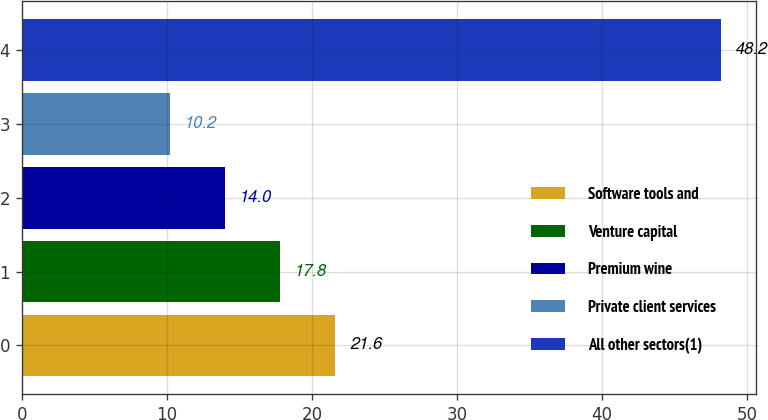Convert chart to OTSL. <chart><loc_0><loc_0><loc_500><loc_500><bar_chart><fcel>Software tools and<fcel>Venture capital<fcel>Premium wine<fcel>Private client services<fcel>All other sectors(1)<nl><fcel>21.6<fcel>17.8<fcel>14<fcel>10.2<fcel>48.2<nl></chart> 